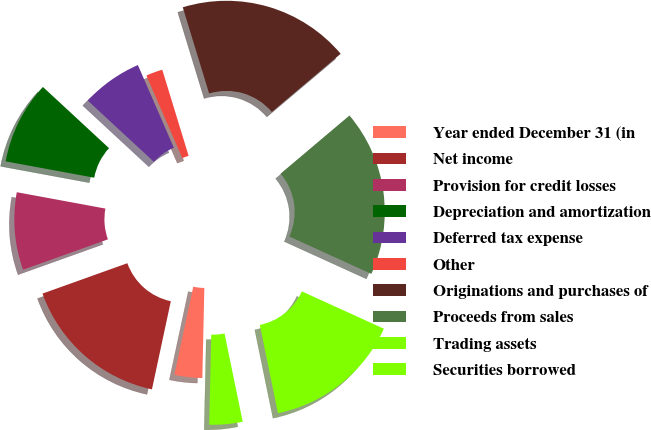Convert chart to OTSL. <chart><loc_0><loc_0><loc_500><loc_500><pie_chart><fcel>Year ended December 31 (in<fcel>Net income<fcel>Provision for credit losses<fcel>Depreciation and amortization<fcel>Deferred tax expense<fcel>Other<fcel>Originations and purchases of<fcel>Proceeds from sales<fcel>Trading assets<fcel>Securities borrowed<nl><fcel>3.0%<fcel>16.17%<fcel>8.38%<fcel>8.98%<fcel>6.59%<fcel>1.8%<fcel>18.56%<fcel>17.96%<fcel>14.97%<fcel>3.59%<nl></chart> 